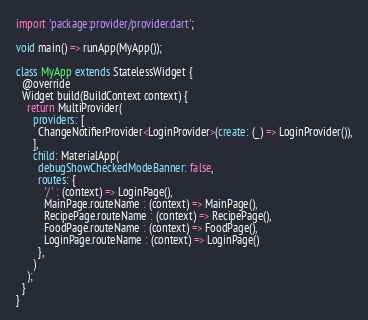Convert code to text. <code><loc_0><loc_0><loc_500><loc_500><_Dart_>import 'package:provider/provider.dart';

void main() => runApp(MyApp());

class MyApp extends StatelessWidget {
  @override
  Widget build(BuildContext context) {
    return MultiProvider(
      providers: [
        ChangeNotifierProvider<LoginProvider>(create: (_) => LoginProvider()),
      ],
      child: MaterialApp(
        debugShowCheckedModeBanner: false,
        routes: {
          '/' : (context) => LoginPage(),
          MainPage.routeName : (context) => MainPage(),
          RecipePage.routeName : (context) => RecipePage(),
          FoodPage.routeName : (context) => FoodPage(),
          LoginPage.routeName : (context) => LoginPage()
        },
      )
    );
  }
}</code> 